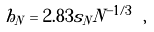<formula> <loc_0><loc_0><loc_500><loc_500>h _ { N } = 2 . 8 3 s _ { N } N ^ { - 1 / 3 } \ ,</formula> 